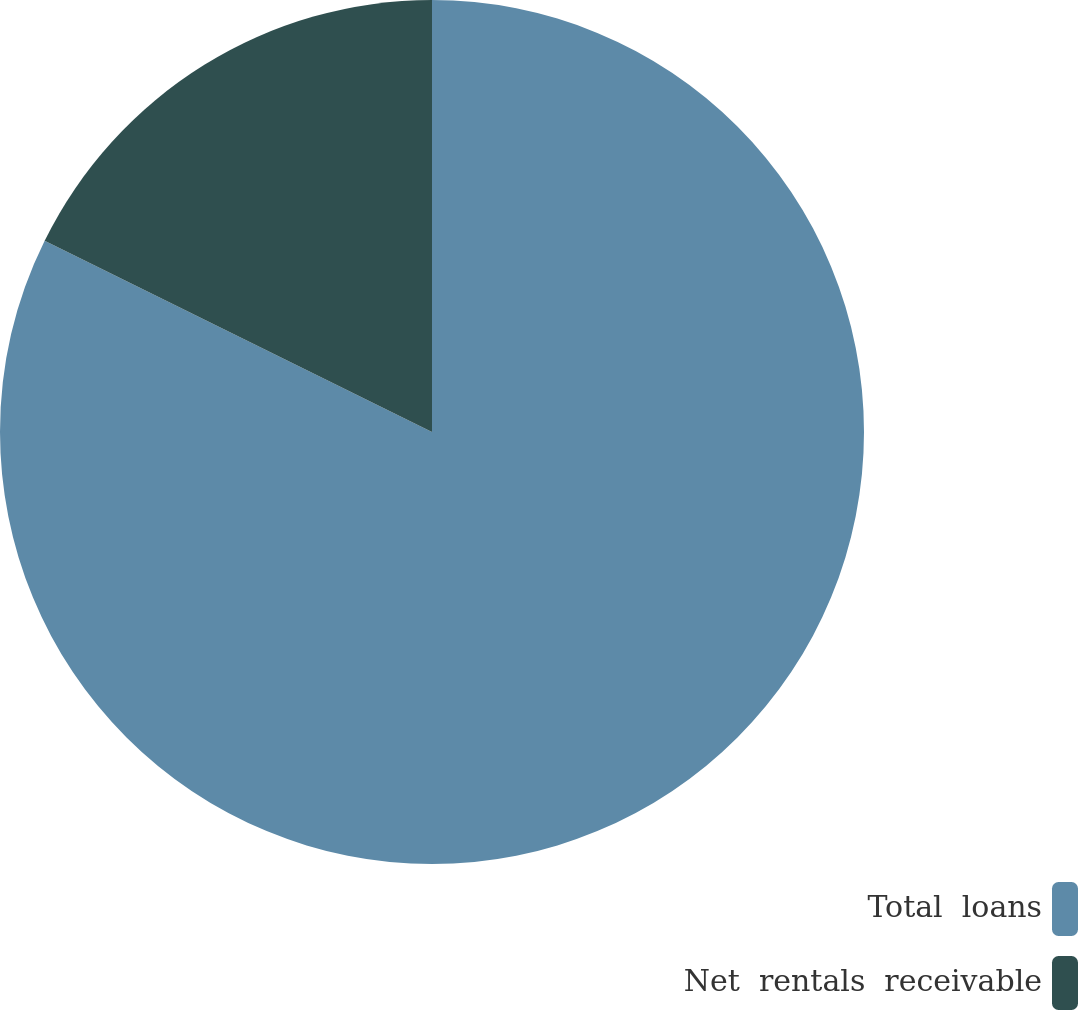Convert chart. <chart><loc_0><loc_0><loc_500><loc_500><pie_chart><fcel>Total  loans<fcel>Net  rentals  receivable<nl><fcel>82.3%<fcel>17.7%<nl></chart> 